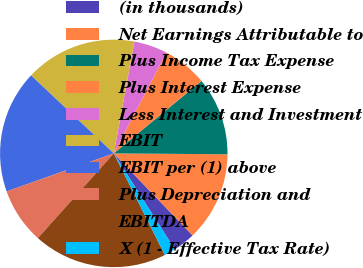Convert chart to OTSL. <chart><loc_0><loc_0><loc_500><loc_500><pie_chart><fcel>(in thousands)<fcel>Net Earnings Attributable to<fcel>Plus Income Tax Expense<fcel>Plus Interest Expense<fcel>Less Interest and Investment<fcel>EBIT<fcel>EBIT per (1) above<fcel>Plus Depreciation and<fcel>EBITDA<fcel>X (1 - Effective Tax Rate)<nl><fcel>3.17%<fcel>12.7%<fcel>11.11%<fcel>6.35%<fcel>4.76%<fcel>15.87%<fcel>17.46%<fcel>7.94%<fcel>19.05%<fcel>1.59%<nl></chart> 